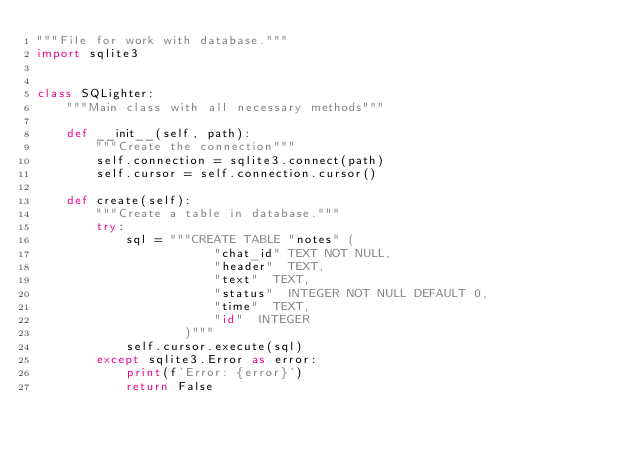Convert code to text. <code><loc_0><loc_0><loc_500><loc_500><_Python_>"""File for work with database."""
import sqlite3


class SQLighter:
    """Main class with all necessary methods"""

    def __init__(self, path):
        """Create the connection"""
        self.connection = sqlite3.connect(path)
        self.cursor = self.connection.cursor()

    def create(self):
        """Create a table in database."""
        try:
            sql = """CREATE TABLE "notes" (
                        "chat_id"	TEXT NOT NULL,
                        "header"	TEXT,
                        "text"	TEXT,
                        "status"	INTEGER NOT NULL DEFAULT 0,
                        "time"	TEXT,
                        "id"	INTEGER
                    )"""
            self.cursor.execute(sql)
        except sqlite3.Error as error:
            print(f'Error: {error}')
            return False</code> 